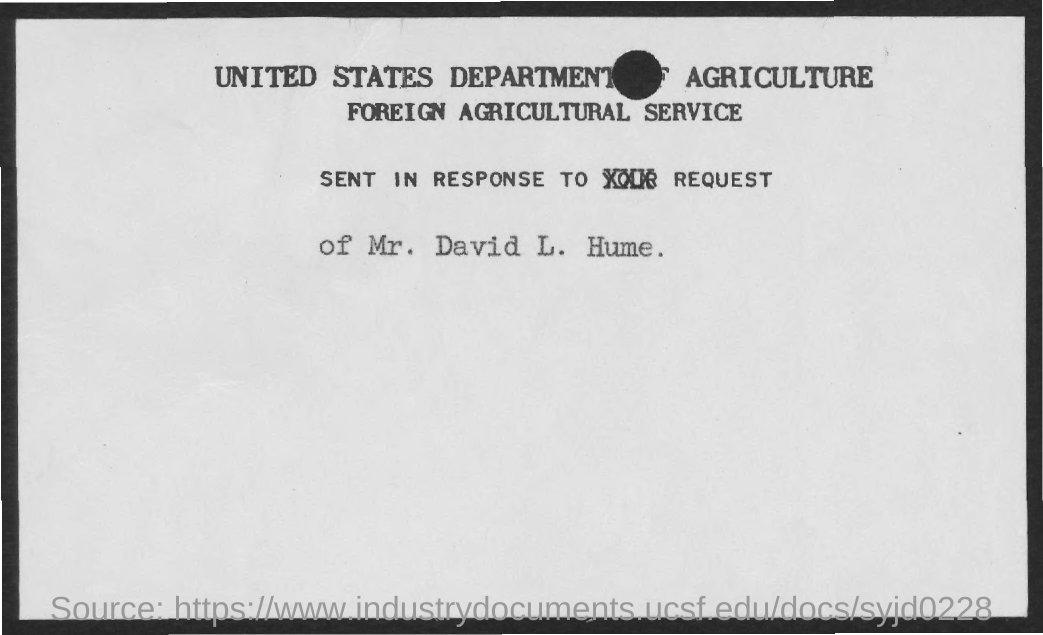What is the second title in the document?
Give a very brief answer. Foreign Agricultural Service. 